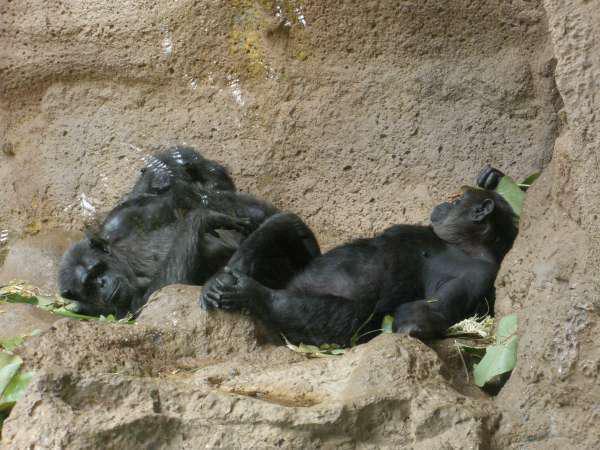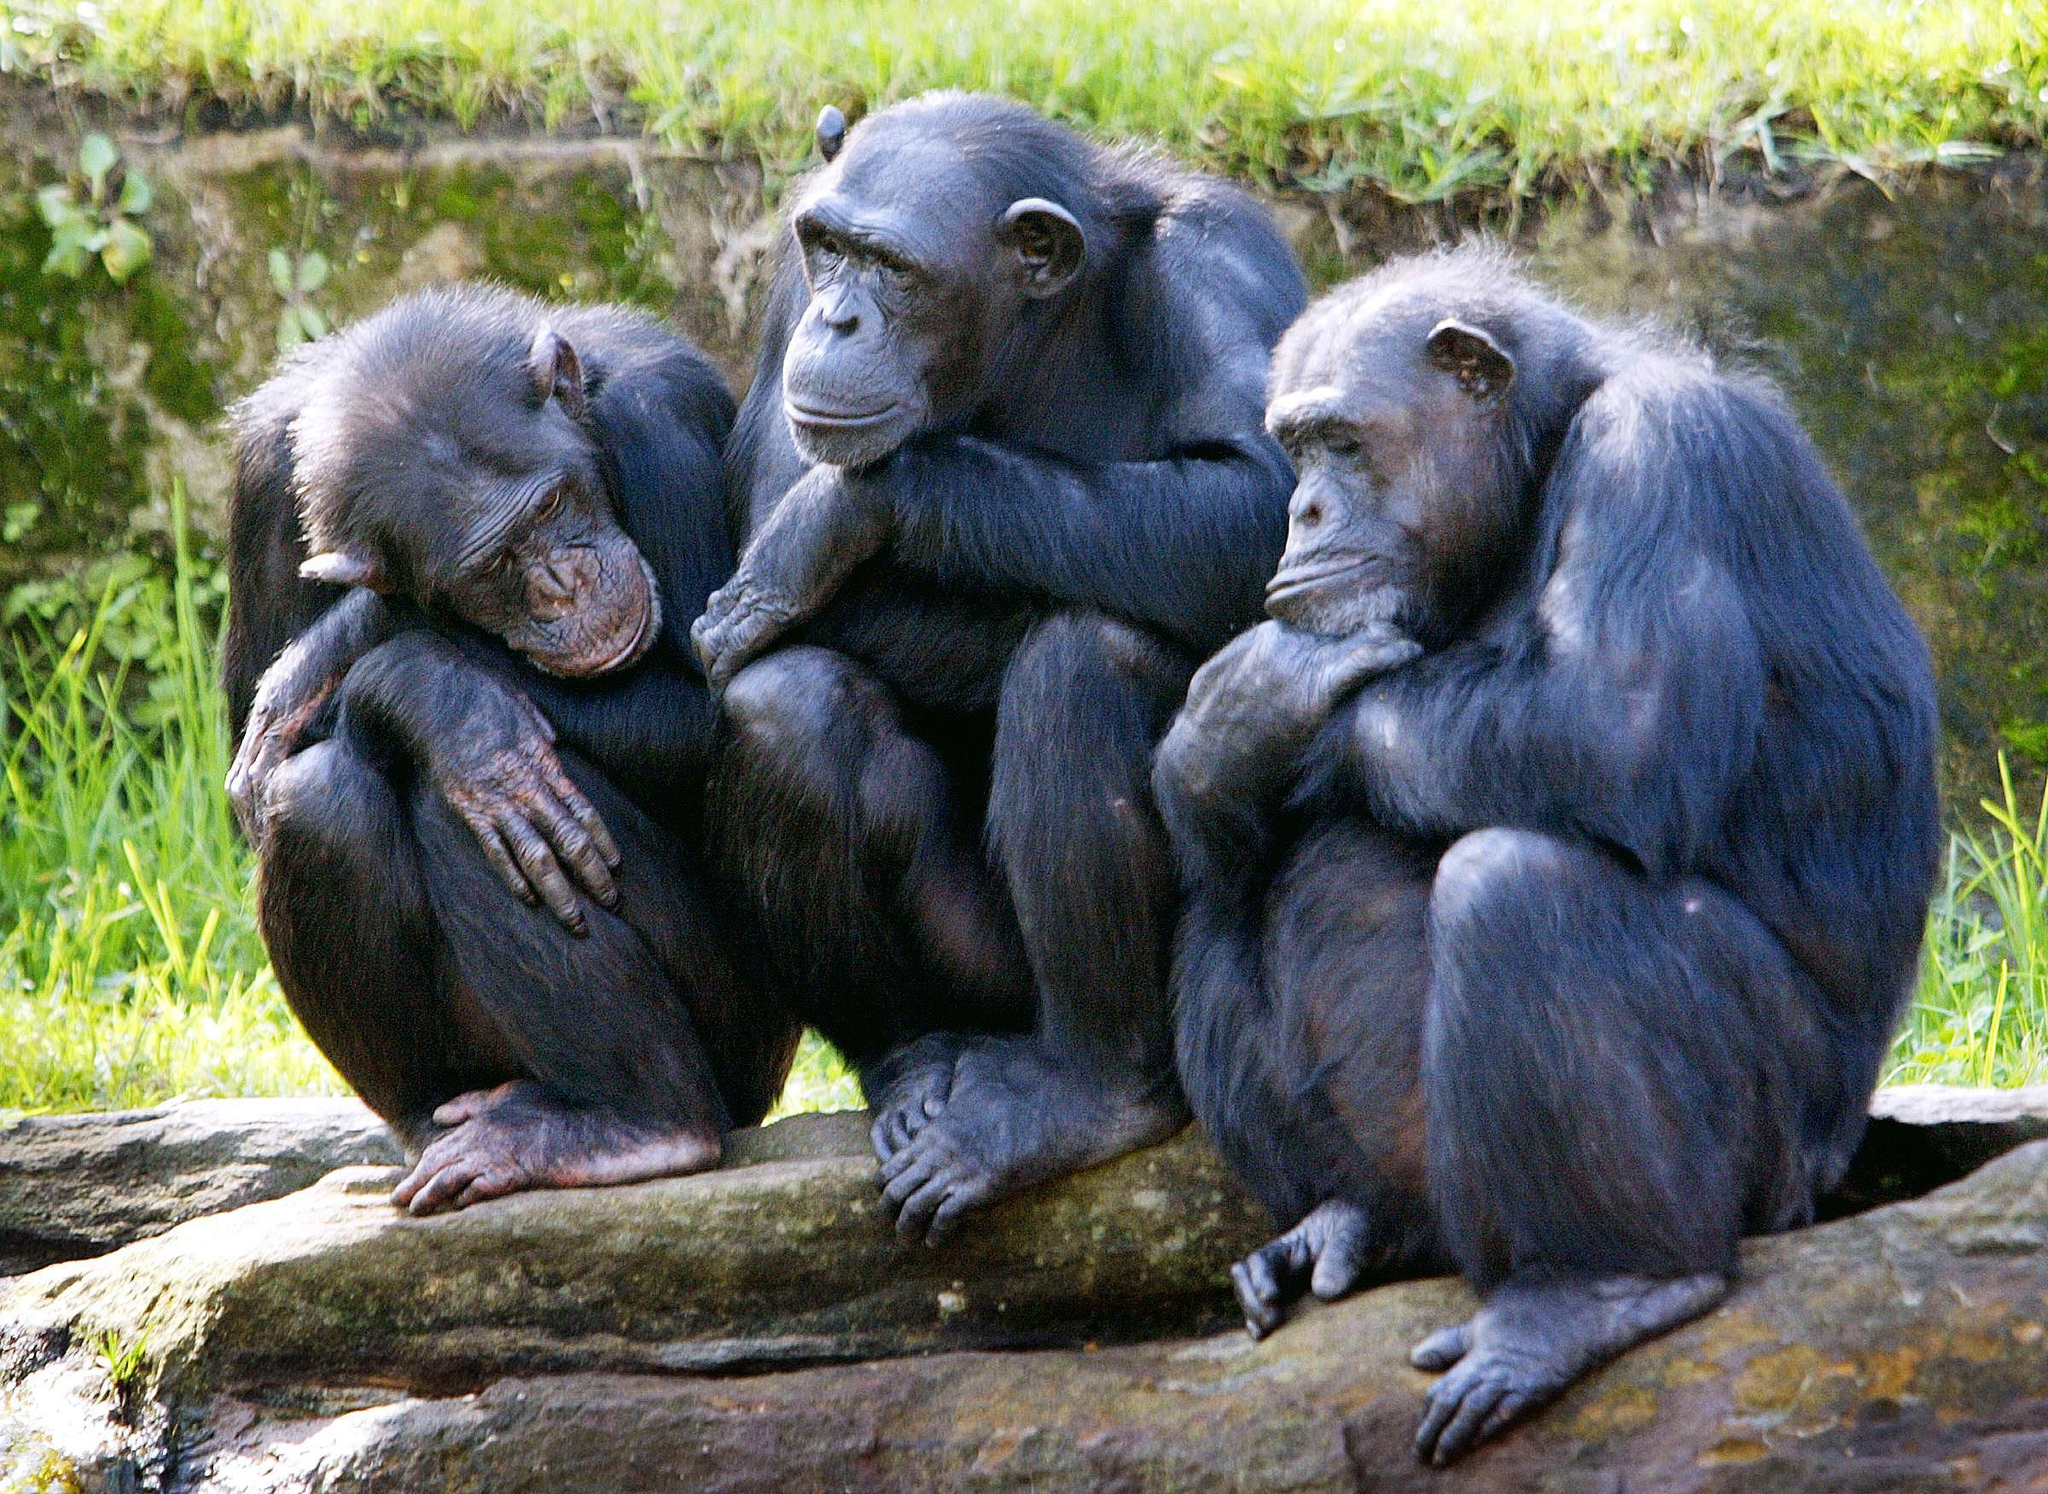The first image is the image on the left, the second image is the image on the right. Given the left and right images, does the statement "Two primates are lying down in one of the images." hold true? Answer yes or no. Yes. The first image is the image on the left, the second image is the image on the right. Given the left and right images, does the statement "In one of the images there are exactly two chimpanzees laying down near each other.." hold true? Answer yes or no. Yes. 